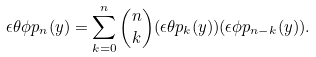<formula> <loc_0><loc_0><loc_500><loc_500>\epsilon \theta \phi p _ { n } ( { y } ) = \sum _ { k = 0 } ^ { n } { n \choose k } ( \epsilon \theta p _ { k } ( { y } ) ) ( \epsilon \phi p _ { n - k } ( { y } ) ) .</formula> 